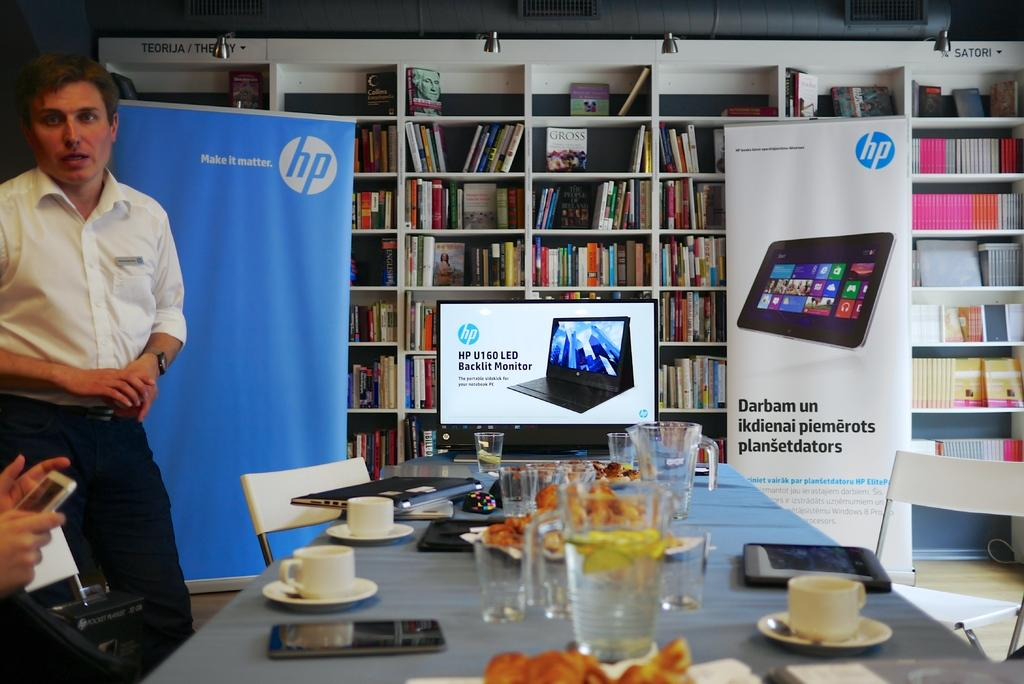<image>
Offer a succinct explanation of the picture presented. A man in a white shirt stands in front of an HP poster with another HP tablet poster being advertised. 